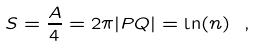<formula> <loc_0><loc_0><loc_500><loc_500>S = \frac { A } { 4 } = 2 \pi | P Q | = \ln ( n ) \ ,</formula> 